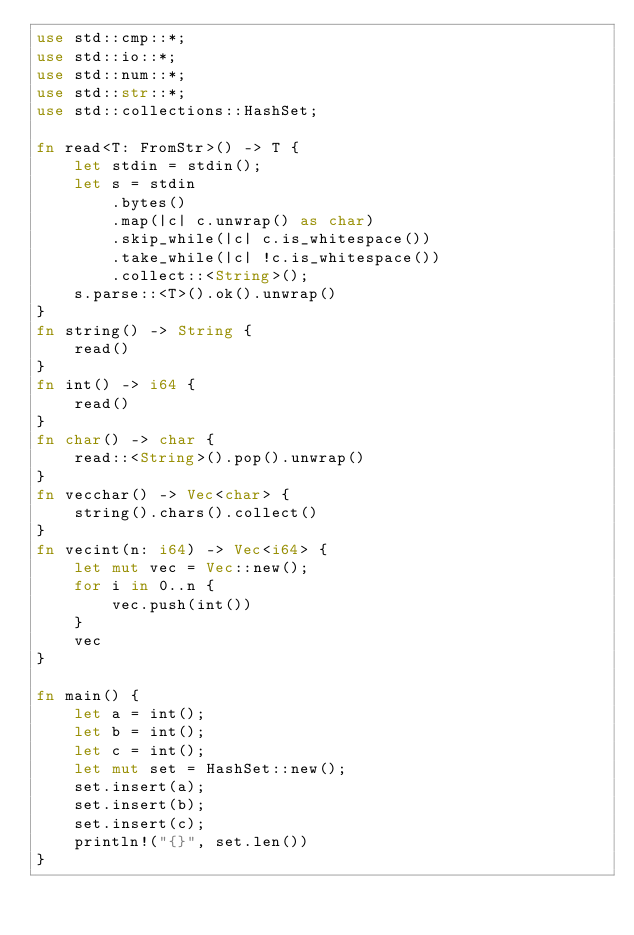<code> <loc_0><loc_0><loc_500><loc_500><_Rust_>use std::cmp::*;
use std::io::*;
use std::num::*;
use std::str::*;
use std::collections::HashSet;

fn read<T: FromStr>() -> T {
    let stdin = stdin();
    let s = stdin
        .bytes()
        .map(|c| c.unwrap() as char)
        .skip_while(|c| c.is_whitespace())
        .take_while(|c| !c.is_whitespace())
        .collect::<String>();
    s.parse::<T>().ok().unwrap()
}
fn string() -> String {
    read()
}
fn int() -> i64 {
    read()
}
fn char() -> char {
    read::<String>().pop().unwrap()
}
fn vecchar() -> Vec<char> {
    string().chars().collect()
}
fn vecint(n: i64) -> Vec<i64> {
    let mut vec = Vec::new();
    for i in 0..n {
        vec.push(int())
    }
    vec
}

fn main() {
    let a = int();
    let b = int();
    let c = int();
    let mut set = HashSet::new();
    set.insert(a);
    set.insert(b);
    set.insert(c);
    println!("{}", set.len())
}
</code> 